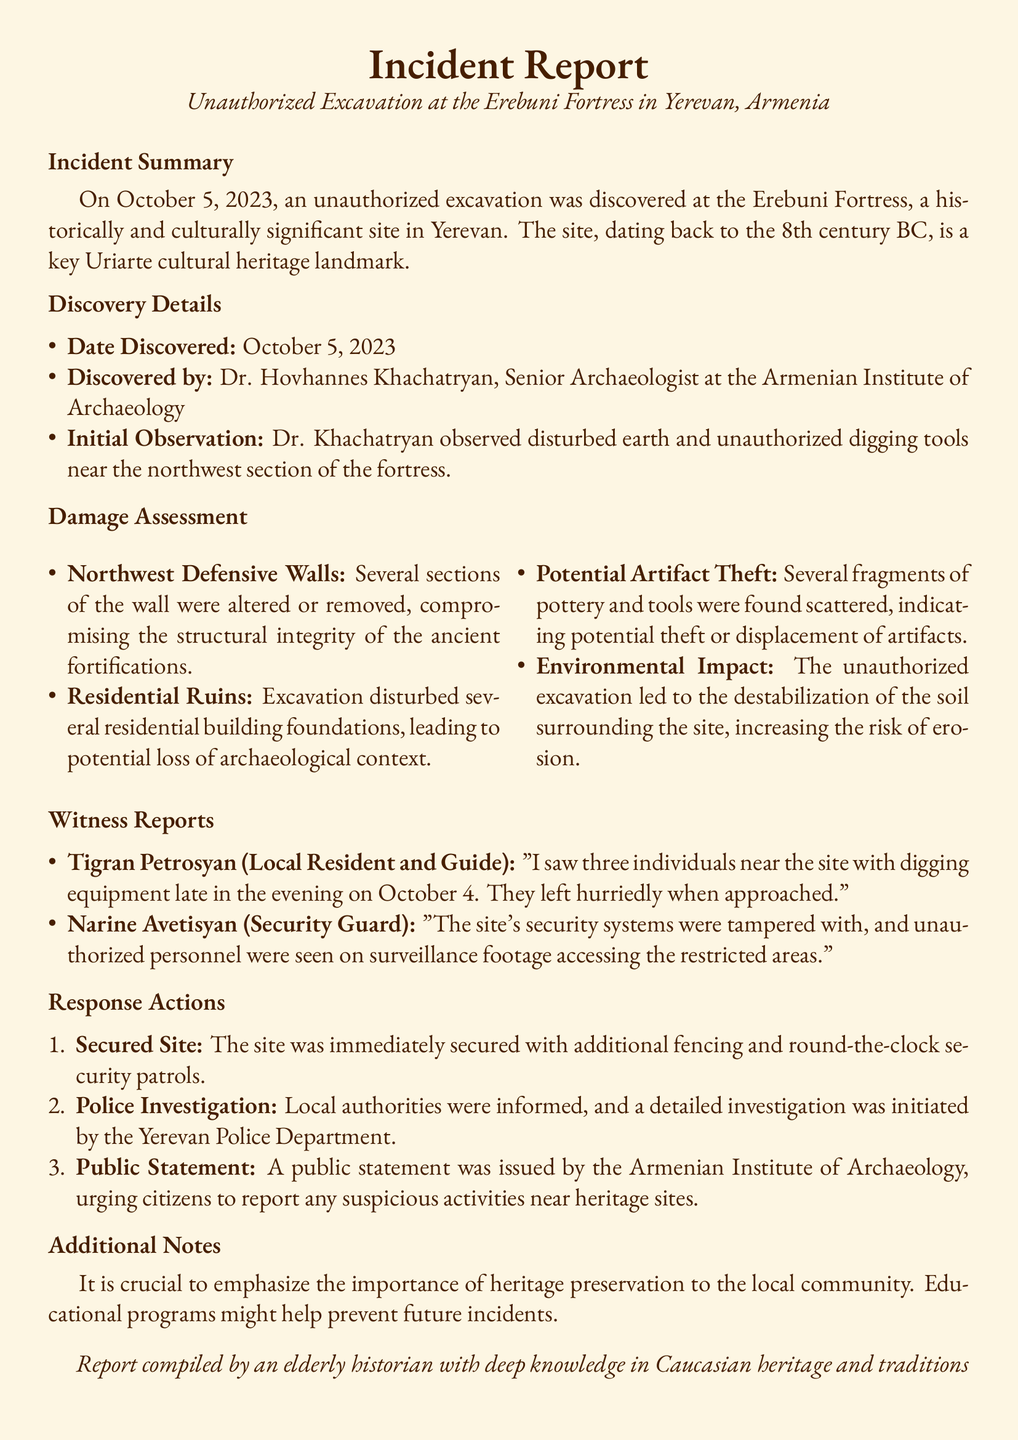What date was the unauthorized excavation discovered? The document states that the unauthorized excavation was discovered on October 5, 2023.
Answer: October 5, 2023 Who discovered the unauthorized excavation? Dr. Hovhannes Khachatryan, Senior Archaeologist at the Armenian Institute of Archaeology, discovered the excavation.
Answer: Dr. Hovhannes Khachatryan What type of damage occurred to the Northwest Defensive Walls? The report mentions that several sections of the wall were altered or removed, compromising its structural integrity.
Answer: Compromised structural integrity What evidence suggests potential artifact theft? The presence of several fragments of pottery and tools scattered at the site indicates potential theft or displacement of artifacts.
Answer: Fragments of pottery and tools How many individuals did Tigran Petrosyan report seeing near the site? According to the witness report, Tigran Petrosyan saw three individuals near the site with digging equipment.
Answer: Three What immediate action was taken to secure the site? The site was immediately secured with additional fencing and round-the-clock security patrols.
Answer: Additional fencing and security patrols What was the public statement about? The public statement urged citizens to report any suspicious activities near heritage sites.
Answer: Report suspicious activities Why is it important to emphasize heritage preservation? Emphasizing heritage preservation is crucial to the local community to prevent future incidents like the unauthorized excavation.
Answer: Prevent future incidents 